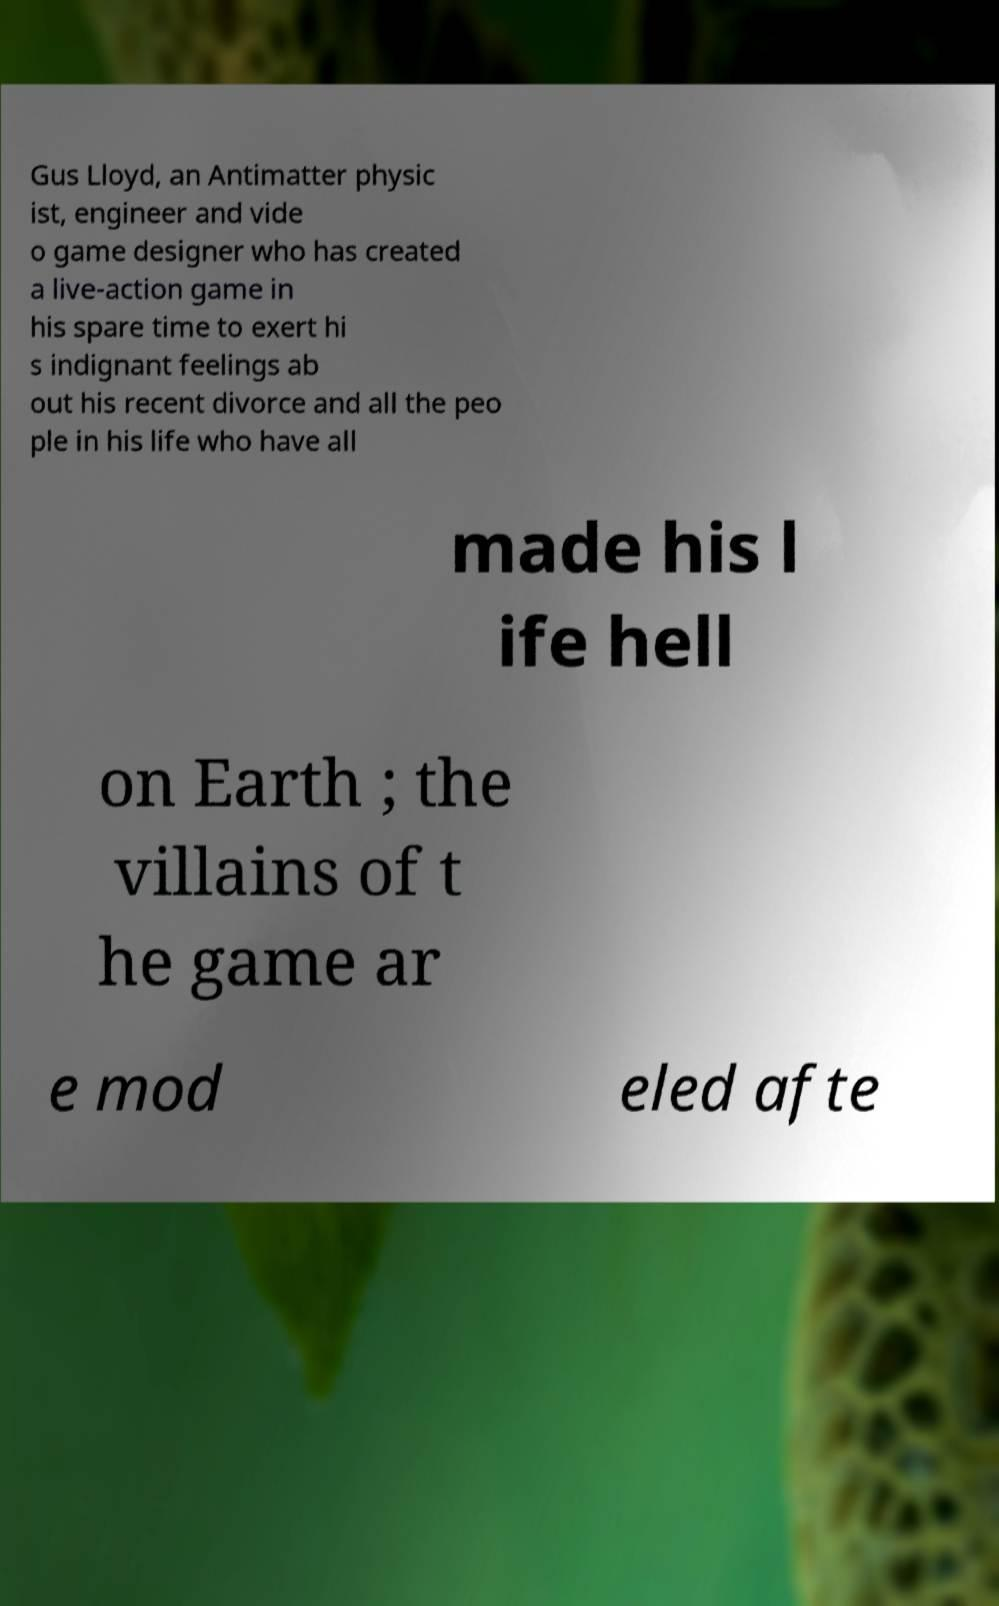Can you accurately transcribe the text from the provided image for me? Gus Lloyd, an Antimatter physic ist, engineer and vide o game designer who has created a live-action game in his spare time to exert hi s indignant feelings ab out his recent divorce and all the peo ple in his life who have all made his l ife hell on Earth ; the villains of t he game ar e mod eled afte 